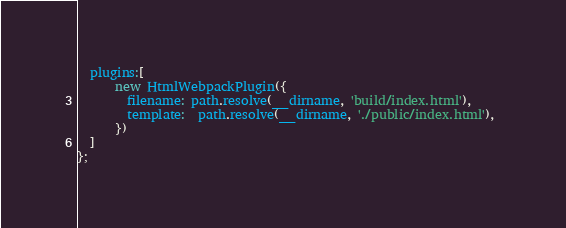Convert code to text. <code><loc_0><loc_0><loc_500><loc_500><_JavaScript_>  plugins:[
      new HtmlWebpackPlugin({
        filename: path.resolve(__dirname, 'build/index.html'),
        template:  path.resolve(__dirname, './public/index.html'), 
      })
  ]
};</code> 